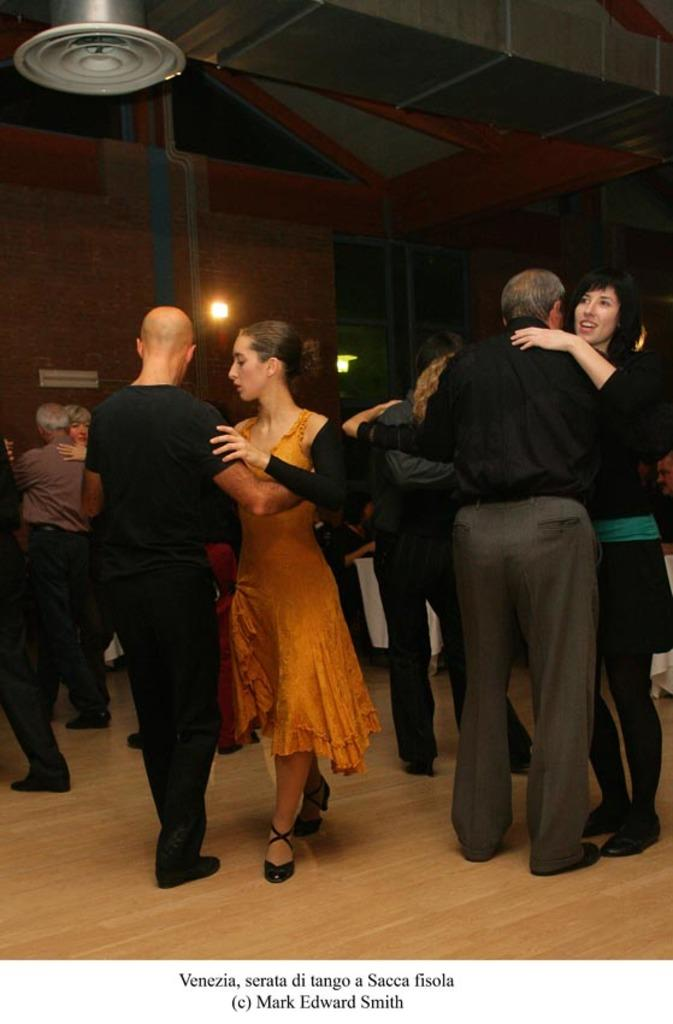How many people are in the image? There is a group of people in the image. What are the people doing in the image? The people are on the ground. What can be seen in the background of the image? There is a wall in the background of the image. What type of horse is being ridden by the maid in the image? There is no horse or maid present in the image. 